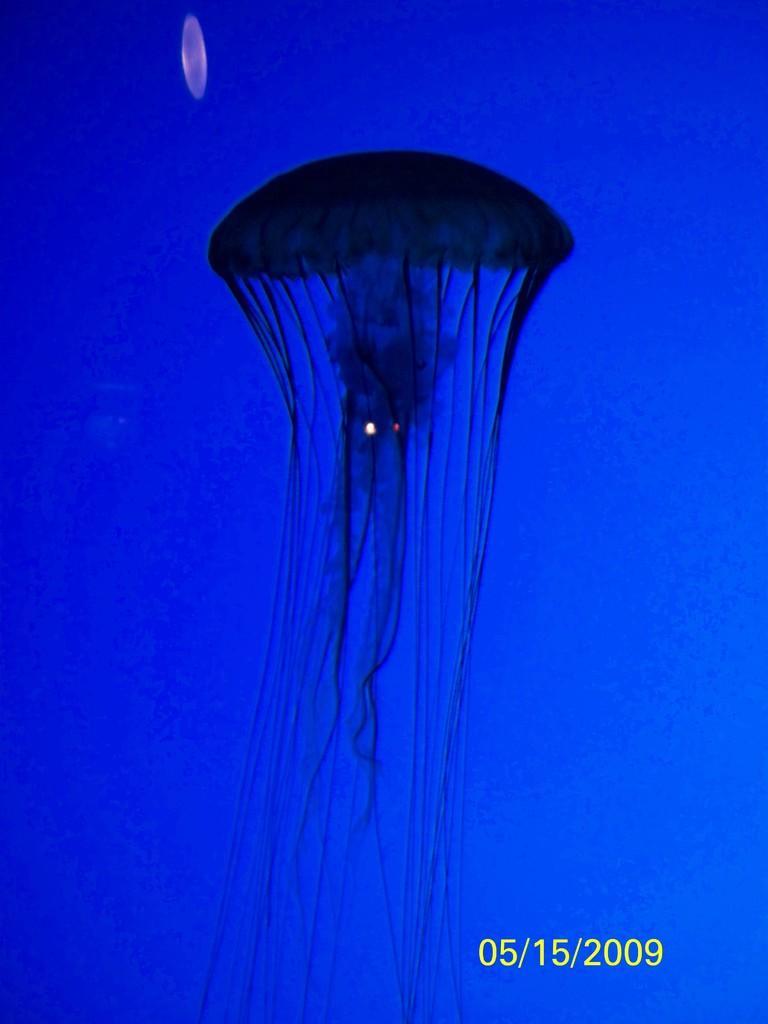How would you summarize this image in a sentence or two? Here we can jellyfish,background it is in blue color. Bottom of the image we can see date. 